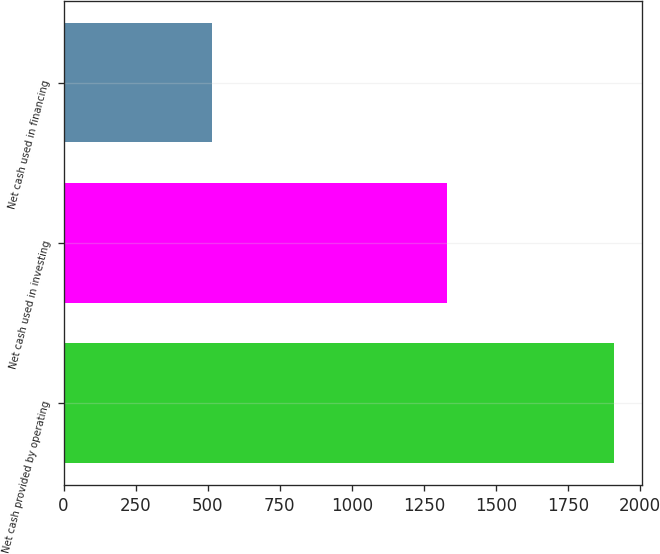Convert chart to OTSL. <chart><loc_0><loc_0><loc_500><loc_500><bar_chart><fcel>Net cash provided by operating<fcel>Net cash used in investing<fcel>Net cash used in financing<nl><fcel>1910.7<fcel>1330.2<fcel>514.4<nl></chart> 